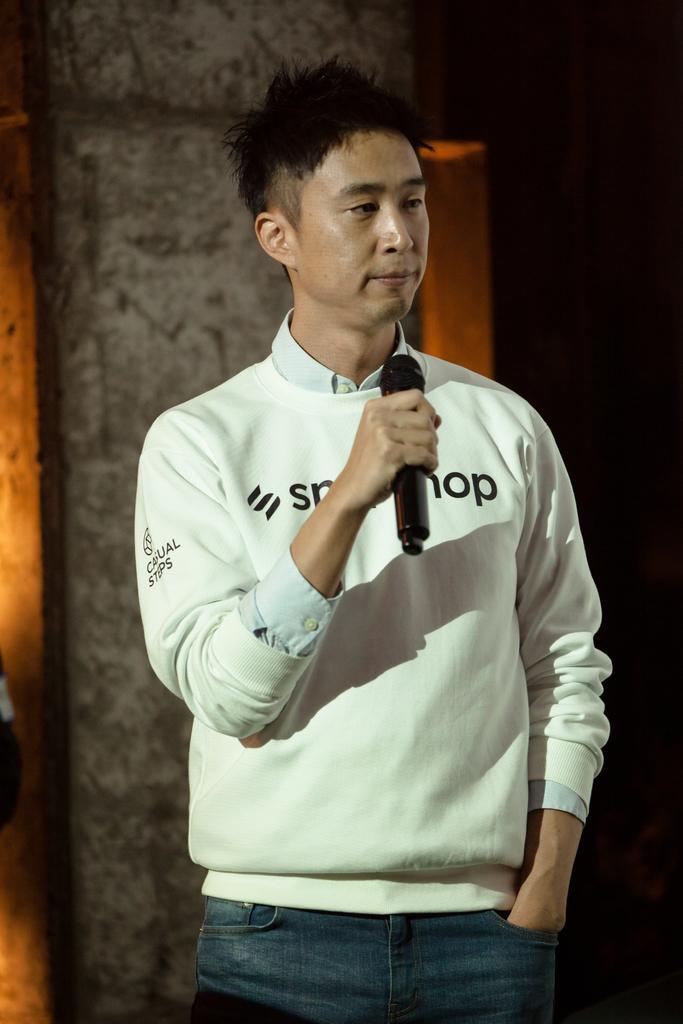Describe this image in one or two sentences. In this image we can see a person standing and holding a microphone. In the background, we can see the wall. 